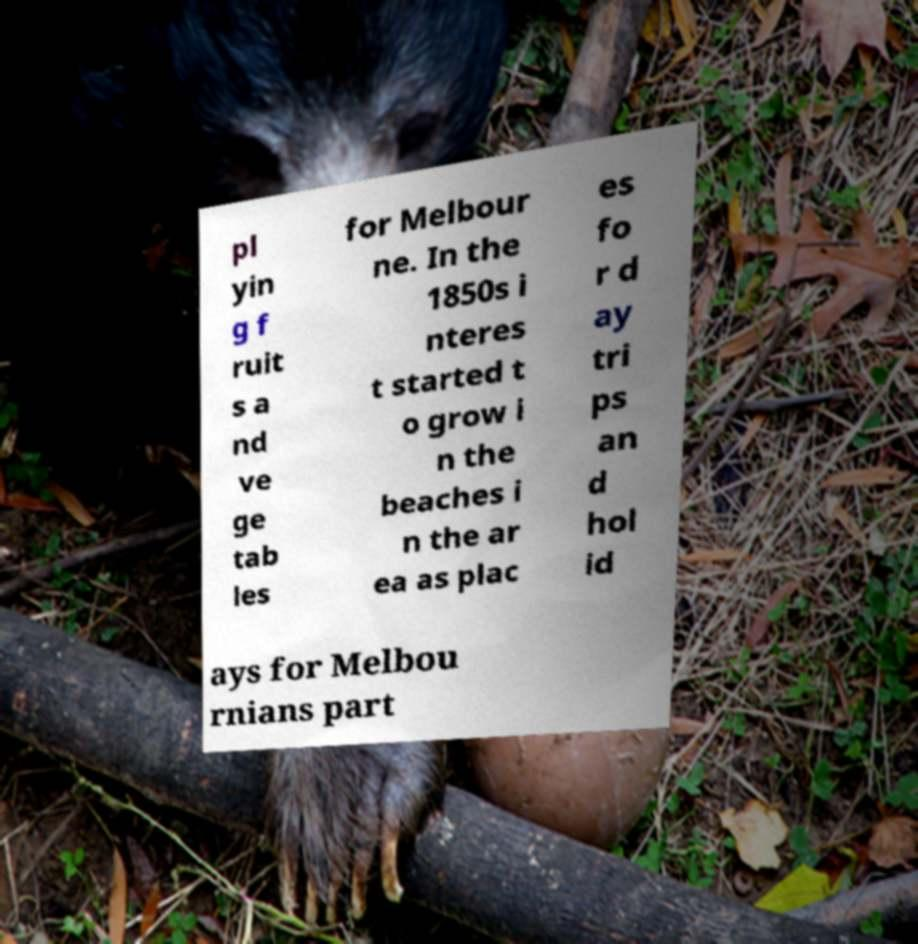Could you assist in decoding the text presented in this image and type it out clearly? pl yin g f ruit s a nd ve ge tab les for Melbour ne. In the 1850s i nteres t started t o grow i n the beaches i n the ar ea as plac es fo r d ay tri ps an d hol id ays for Melbou rnians part 